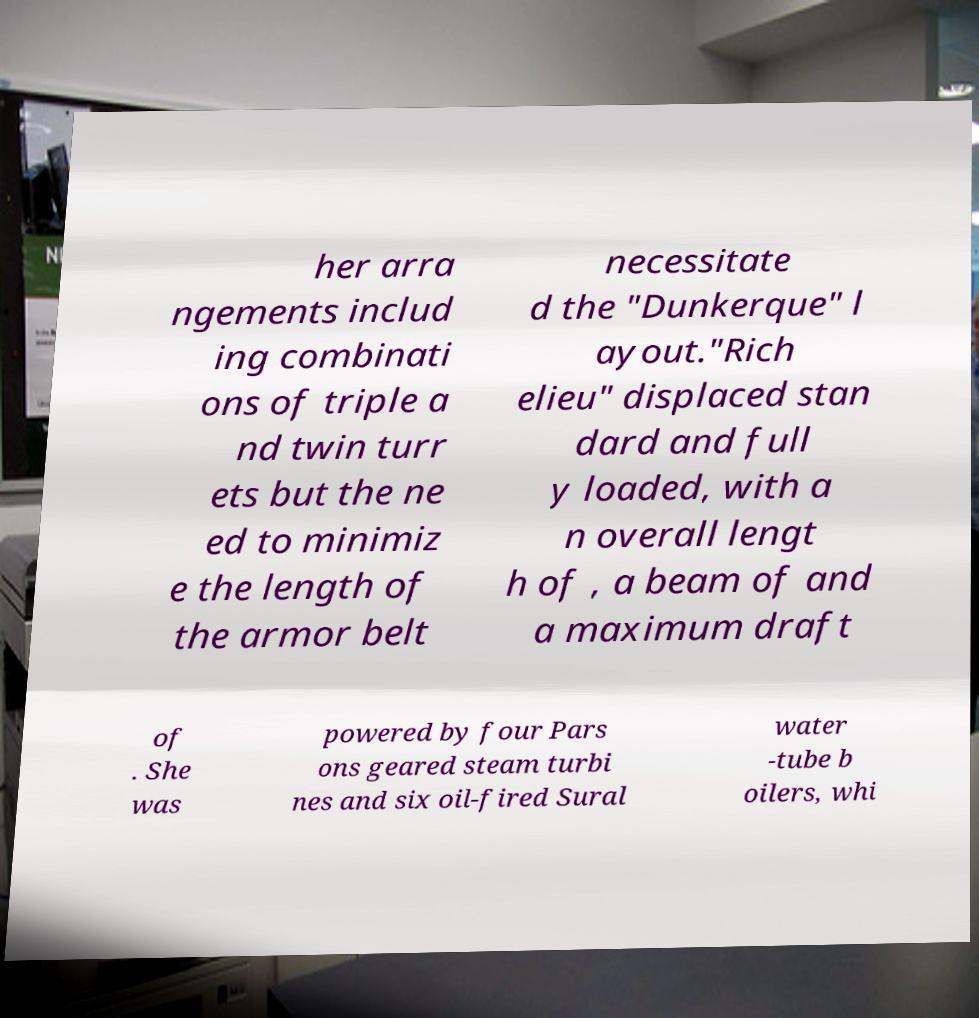Could you extract and type out the text from this image? her arra ngements includ ing combinati ons of triple a nd twin turr ets but the ne ed to minimiz e the length of the armor belt necessitate d the "Dunkerque" l ayout."Rich elieu" displaced stan dard and full y loaded, with a n overall lengt h of , a beam of and a maximum draft of . She was powered by four Pars ons geared steam turbi nes and six oil-fired Sural water -tube b oilers, whi 